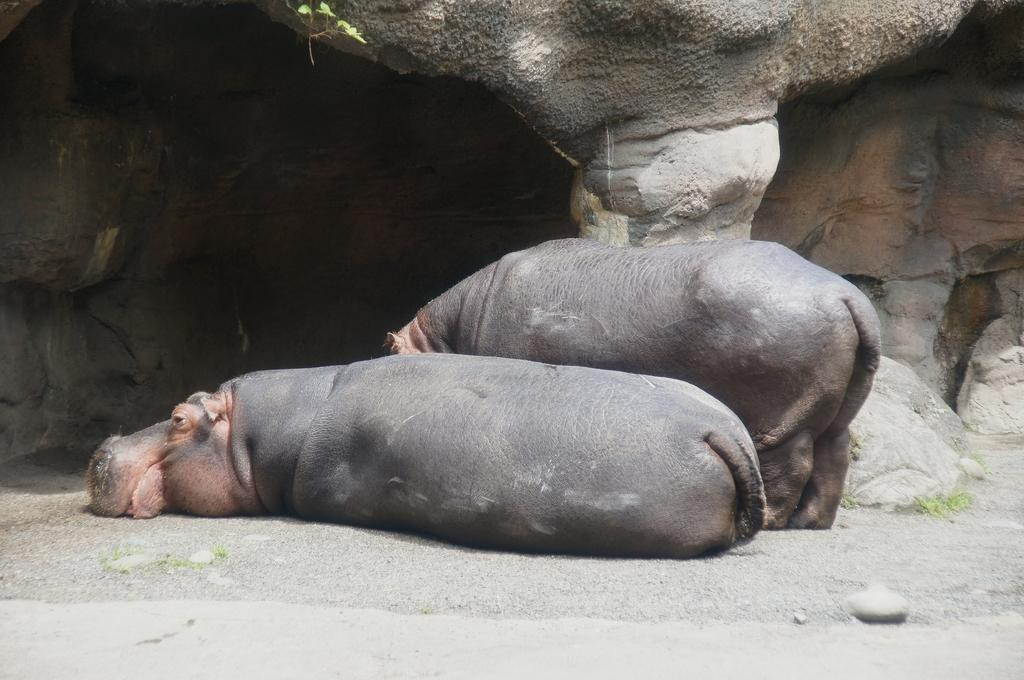What animals are present in the image? There are hippopotami in the image. What are the hippopotami doing in the image? Some hippopotami are lying on the ground, while others are standing on the ground. What can be seen in the background of the image? There are rocks in the background of the image. Where is the rabbit hiding in the image? There is no rabbit present in the image; it features hippopotami and rocks. What is the heart rate of the hippopotami in the image? We cannot determine the heart rate of the hippopotami from the image alone, as it does not provide information about their physical condition or activity level. 